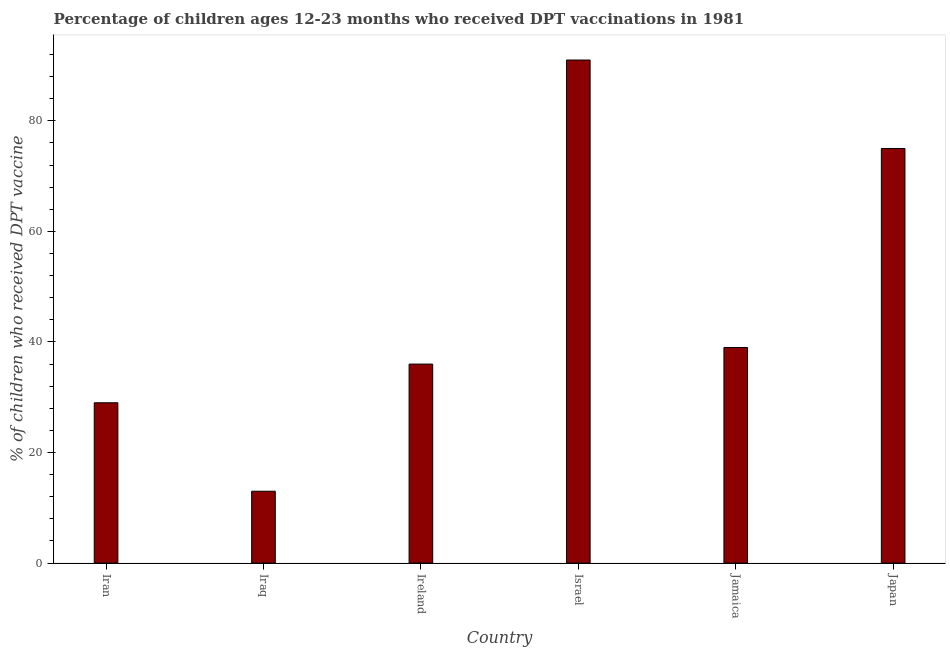Does the graph contain grids?
Provide a succinct answer. No. What is the title of the graph?
Offer a terse response. Percentage of children ages 12-23 months who received DPT vaccinations in 1981. What is the label or title of the X-axis?
Your answer should be compact. Country. What is the label or title of the Y-axis?
Offer a terse response. % of children who received DPT vaccine. Across all countries, what is the maximum percentage of children who received dpt vaccine?
Offer a very short reply. 91. In which country was the percentage of children who received dpt vaccine maximum?
Your response must be concise. Israel. In which country was the percentage of children who received dpt vaccine minimum?
Make the answer very short. Iraq. What is the sum of the percentage of children who received dpt vaccine?
Make the answer very short. 283. What is the difference between the percentage of children who received dpt vaccine in Israel and Japan?
Provide a short and direct response. 16. What is the average percentage of children who received dpt vaccine per country?
Provide a short and direct response. 47.17. What is the median percentage of children who received dpt vaccine?
Offer a very short reply. 37.5. In how many countries, is the percentage of children who received dpt vaccine greater than 12 %?
Offer a very short reply. 6. What is the ratio of the percentage of children who received dpt vaccine in Iraq to that in Ireland?
Ensure brevity in your answer.  0.36. Is the difference between the percentage of children who received dpt vaccine in Israel and Jamaica greater than the difference between any two countries?
Provide a succinct answer. No. What is the difference between the highest and the second highest percentage of children who received dpt vaccine?
Provide a short and direct response. 16. Is the sum of the percentage of children who received dpt vaccine in Iraq and Jamaica greater than the maximum percentage of children who received dpt vaccine across all countries?
Provide a short and direct response. No. In how many countries, is the percentage of children who received dpt vaccine greater than the average percentage of children who received dpt vaccine taken over all countries?
Provide a short and direct response. 2. How many bars are there?
Provide a succinct answer. 6. Are all the bars in the graph horizontal?
Your answer should be very brief. No. What is the difference between two consecutive major ticks on the Y-axis?
Offer a terse response. 20. Are the values on the major ticks of Y-axis written in scientific E-notation?
Offer a very short reply. No. What is the % of children who received DPT vaccine in Israel?
Give a very brief answer. 91. What is the % of children who received DPT vaccine in Japan?
Make the answer very short. 75. What is the difference between the % of children who received DPT vaccine in Iran and Iraq?
Ensure brevity in your answer.  16. What is the difference between the % of children who received DPT vaccine in Iran and Israel?
Provide a succinct answer. -62. What is the difference between the % of children who received DPT vaccine in Iran and Jamaica?
Give a very brief answer. -10. What is the difference between the % of children who received DPT vaccine in Iran and Japan?
Ensure brevity in your answer.  -46. What is the difference between the % of children who received DPT vaccine in Iraq and Israel?
Your answer should be very brief. -78. What is the difference between the % of children who received DPT vaccine in Iraq and Jamaica?
Offer a very short reply. -26. What is the difference between the % of children who received DPT vaccine in Iraq and Japan?
Provide a short and direct response. -62. What is the difference between the % of children who received DPT vaccine in Ireland and Israel?
Offer a terse response. -55. What is the difference between the % of children who received DPT vaccine in Ireland and Jamaica?
Give a very brief answer. -3. What is the difference between the % of children who received DPT vaccine in Ireland and Japan?
Provide a succinct answer. -39. What is the difference between the % of children who received DPT vaccine in Jamaica and Japan?
Your answer should be very brief. -36. What is the ratio of the % of children who received DPT vaccine in Iran to that in Iraq?
Your answer should be very brief. 2.23. What is the ratio of the % of children who received DPT vaccine in Iran to that in Ireland?
Your answer should be compact. 0.81. What is the ratio of the % of children who received DPT vaccine in Iran to that in Israel?
Your answer should be very brief. 0.32. What is the ratio of the % of children who received DPT vaccine in Iran to that in Jamaica?
Your answer should be compact. 0.74. What is the ratio of the % of children who received DPT vaccine in Iran to that in Japan?
Ensure brevity in your answer.  0.39. What is the ratio of the % of children who received DPT vaccine in Iraq to that in Ireland?
Keep it short and to the point. 0.36. What is the ratio of the % of children who received DPT vaccine in Iraq to that in Israel?
Give a very brief answer. 0.14. What is the ratio of the % of children who received DPT vaccine in Iraq to that in Jamaica?
Keep it short and to the point. 0.33. What is the ratio of the % of children who received DPT vaccine in Iraq to that in Japan?
Provide a succinct answer. 0.17. What is the ratio of the % of children who received DPT vaccine in Ireland to that in Israel?
Provide a short and direct response. 0.4. What is the ratio of the % of children who received DPT vaccine in Ireland to that in Jamaica?
Offer a terse response. 0.92. What is the ratio of the % of children who received DPT vaccine in Ireland to that in Japan?
Provide a short and direct response. 0.48. What is the ratio of the % of children who received DPT vaccine in Israel to that in Jamaica?
Provide a short and direct response. 2.33. What is the ratio of the % of children who received DPT vaccine in Israel to that in Japan?
Offer a very short reply. 1.21. What is the ratio of the % of children who received DPT vaccine in Jamaica to that in Japan?
Your answer should be very brief. 0.52. 